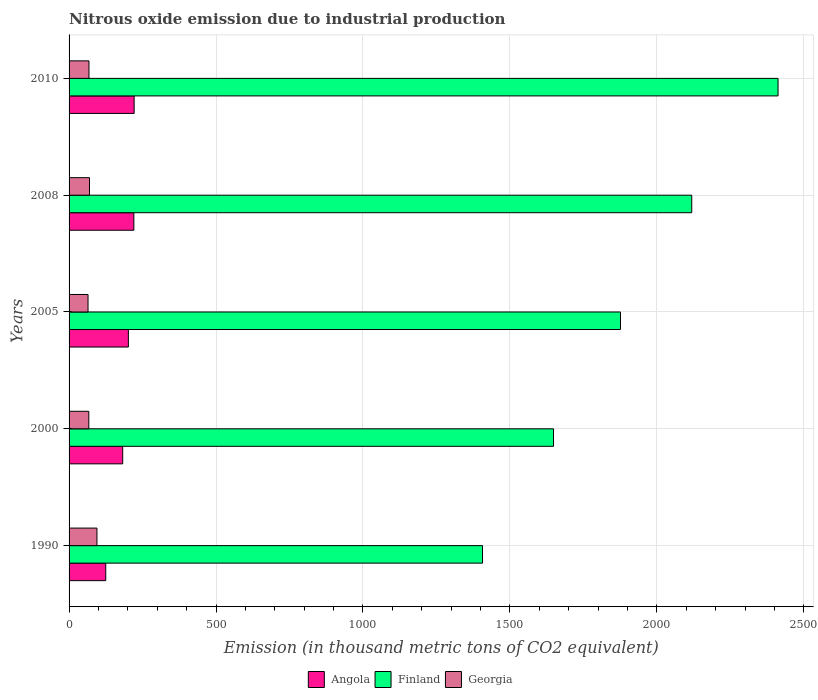How many different coloured bars are there?
Give a very brief answer. 3. How many groups of bars are there?
Your answer should be very brief. 5. Are the number of bars on each tick of the Y-axis equal?
Provide a succinct answer. Yes. How many bars are there on the 2nd tick from the bottom?
Offer a very short reply. 3. In how many cases, is the number of bars for a given year not equal to the number of legend labels?
Your response must be concise. 0. What is the amount of nitrous oxide emitted in Angola in 2005?
Ensure brevity in your answer.  201.8. Across all years, what is the maximum amount of nitrous oxide emitted in Georgia?
Ensure brevity in your answer.  94.9. Across all years, what is the minimum amount of nitrous oxide emitted in Angola?
Offer a very short reply. 124.8. What is the total amount of nitrous oxide emitted in Angola in the graph?
Offer a terse response. 950.9. What is the difference between the amount of nitrous oxide emitted in Angola in 2000 and that in 2010?
Provide a short and direct response. -38.9. What is the difference between the amount of nitrous oxide emitted in Angola in 1990 and the amount of nitrous oxide emitted in Finland in 2000?
Your answer should be very brief. -1523.6. What is the average amount of nitrous oxide emitted in Georgia per year?
Your answer should be compact. 72.76. In the year 1990, what is the difference between the amount of nitrous oxide emitted in Angola and amount of nitrous oxide emitted in Finland?
Offer a terse response. -1282. In how many years, is the amount of nitrous oxide emitted in Angola greater than 1800 thousand metric tons?
Ensure brevity in your answer.  0. What is the ratio of the amount of nitrous oxide emitted in Angola in 1990 to that in 2005?
Offer a very short reply. 0.62. Is the amount of nitrous oxide emitted in Angola in 2005 less than that in 2008?
Provide a short and direct response. Yes. What is the difference between the highest and the second highest amount of nitrous oxide emitted in Finland?
Give a very brief answer. 293.7. What is the difference between the highest and the lowest amount of nitrous oxide emitted in Georgia?
Your answer should be very brief. 30.4. What does the 2nd bar from the bottom in 2008 represents?
Provide a short and direct response. Finland. Does the graph contain grids?
Provide a short and direct response. Yes. How are the legend labels stacked?
Keep it short and to the point. Horizontal. What is the title of the graph?
Provide a succinct answer. Nitrous oxide emission due to industrial production. Does "Algeria" appear as one of the legend labels in the graph?
Provide a short and direct response. No. What is the label or title of the X-axis?
Give a very brief answer. Emission (in thousand metric tons of CO2 equivalent). What is the label or title of the Y-axis?
Provide a short and direct response. Years. What is the Emission (in thousand metric tons of CO2 equivalent) in Angola in 1990?
Your answer should be very brief. 124.8. What is the Emission (in thousand metric tons of CO2 equivalent) of Finland in 1990?
Your answer should be very brief. 1406.8. What is the Emission (in thousand metric tons of CO2 equivalent) of Georgia in 1990?
Keep it short and to the point. 94.9. What is the Emission (in thousand metric tons of CO2 equivalent) of Angola in 2000?
Your response must be concise. 182.5. What is the Emission (in thousand metric tons of CO2 equivalent) of Finland in 2000?
Provide a short and direct response. 1648.4. What is the Emission (in thousand metric tons of CO2 equivalent) of Georgia in 2000?
Make the answer very short. 67.2. What is the Emission (in thousand metric tons of CO2 equivalent) in Angola in 2005?
Make the answer very short. 201.8. What is the Emission (in thousand metric tons of CO2 equivalent) in Finland in 2005?
Your answer should be compact. 1876.3. What is the Emission (in thousand metric tons of CO2 equivalent) in Georgia in 2005?
Your response must be concise. 64.5. What is the Emission (in thousand metric tons of CO2 equivalent) of Angola in 2008?
Your response must be concise. 220.4. What is the Emission (in thousand metric tons of CO2 equivalent) of Finland in 2008?
Offer a very short reply. 2118.7. What is the Emission (in thousand metric tons of CO2 equivalent) in Georgia in 2008?
Offer a very short reply. 69.5. What is the Emission (in thousand metric tons of CO2 equivalent) in Angola in 2010?
Your response must be concise. 221.4. What is the Emission (in thousand metric tons of CO2 equivalent) of Finland in 2010?
Provide a succinct answer. 2412.4. What is the Emission (in thousand metric tons of CO2 equivalent) of Georgia in 2010?
Provide a short and direct response. 67.7. Across all years, what is the maximum Emission (in thousand metric tons of CO2 equivalent) in Angola?
Your answer should be very brief. 221.4. Across all years, what is the maximum Emission (in thousand metric tons of CO2 equivalent) in Finland?
Your answer should be compact. 2412.4. Across all years, what is the maximum Emission (in thousand metric tons of CO2 equivalent) in Georgia?
Give a very brief answer. 94.9. Across all years, what is the minimum Emission (in thousand metric tons of CO2 equivalent) in Angola?
Provide a short and direct response. 124.8. Across all years, what is the minimum Emission (in thousand metric tons of CO2 equivalent) of Finland?
Give a very brief answer. 1406.8. Across all years, what is the minimum Emission (in thousand metric tons of CO2 equivalent) of Georgia?
Keep it short and to the point. 64.5. What is the total Emission (in thousand metric tons of CO2 equivalent) in Angola in the graph?
Offer a terse response. 950.9. What is the total Emission (in thousand metric tons of CO2 equivalent) of Finland in the graph?
Your answer should be very brief. 9462.6. What is the total Emission (in thousand metric tons of CO2 equivalent) in Georgia in the graph?
Provide a short and direct response. 363.8. What is the difference between the Emission (in thousand metric tons of CO2 equivalent) in Angola in 1990 and that in 2000?
Provide a short and direct response. -57.7. What is the difference between the Emission (in thousand metric tons of CO2 equivalent) in Finland in 1990 and that in 2000?
Offer a very short reply. -241.6. What is the difference between the Emission (in thousand metric tons of CO2 equivalent) of Georgia in 1990 and that in 2000?
Make the answer very short. 27.7. What is the difference between the Emission (in thousand metric tons of CO2 equivalent) of Angola in 1990 and that in 2005?
Provide a succinct answer. -77. What is the difference between the Emission (in thousand metric tons of CO2 equivalent) in Finland in 1990 and that in 2005?
Make the answer very short. -469.5. What is the difference between the Emission (in thousand metric tons of CO2 equivalent) in Georgia in 1990 and that in 2005?
Provide a short and direct response. 30.4. What is the difference between the Emission (in thousand metric tons of CO2 equivalent) in Angola in 1990 and that in 2008?
Offer a terse response. -95.6. What is the difference between the Emission (in thousand metric tons of CO2 equivalent) in Finland in 1990 and that in 2008?
Give a very brief answer. -711.9. What is the difference between the Emission (in thousand metric tons of CO2 equivalent) in Georgia in 1990 and that in 2008?
Ensure brevity in your answer.  25.4. What is the difference between the Emission (in thousand metric tons of CO2 equivalent) in Angola in 1990 and that in 2010?
Keep it short and to the point. -96.6. What is the difference between the Emission (in thousand metric tons of CO2 equivalent) in Finland in 1990 and that in 2010?
Provide a short and direct response. -1005.6. What is the difference between the Emission (in thousand metric tons of CO2 equivalent) in Georgia in 1990 and that in 2010?
Offer a very short reply. 27.2. What is the difference between the Emission (in thousand metric tons of CO2 equivalent) of Angola in 2000 and that in 2005?
Offer a very short reply. -19.3. What is the difference between the Emission (in thousand metric tons of CO2 equivalent) in Finland in 2000 and that in 2005?
Give a very brief answer. -227.9. What is the difference between the Emission (in thousand metric tons of CO2 equivalent) of Georgia in 2000 and that in 2005?
Your response must be concise. 2.7. What is the difference between the Emission (in thousand metric tons of CO2 equivalent) in Angola in 2000 and that in 2008?
Make the answer very short. -37.9. What is the difference between the Emission (in thousand metric tons of CO2 equivalent) of Finland in 2000 and that in 2008?
Give a very brief answer. -470.3. What is the difference between the Emission (in thousand metric tons of CO2 equivalent) of Georgia in 2000 and that in 2008?
Provide a succinct answer. -2.3. What is the difference between the Emission (in thousand metric tons of CO2 equivalent) in Angola in 2000 and that in 2010?
Provide a succinct answer. -38.9. What is the difference between the Emission (in thousand metric tons of CO2 equivalent) in Finland in 2000 and that in 2010?
Provide a succinct answer. -764. What is the difference between the Emission (in thousand metric tons of CO2 equivalent) of Georgia in 2000 and that in 2010?
Provide a succinct answer. -0.5. What is the difference between the Emission (in thousand metric tons of CO2 equivalent) of Angola in 2005 and that in 2008?
Give a very brief answer. -18.6. What is the difference between the Emission (in thousand metric tons of CO2 equivalent) in Finland in 2005 and that in 2008?
Give a very brief answer. -242.4. What is the difference between the Emission (in thousand metric tons of CO2 equivalent) in Georgia in 2005 and that in 2008?
Make the answer very short. -5. What is the difference between the Emission (in thousand metric tons of CO2 equivalent) of Angola in 2005 and that in 2010?
Keep it short and to the point. -19.6. What is the difference between the Emission (in thousand metric tons of CO2 equivalent) in Finland in 2005 and that in 2010?
Give a very brief answer. -536.1. What is the difference between the Emission (in thousand metric tons of CO2 equivalent) of Angola in 2008 and that in 2010?
Make the answer very short. -1. What is the difference between the Emission (in thousand metric tons of CO2 equivalent) of Finland in 2008 and that in 2010?
Your answer should be very brief. -293.7. What is the difference between the Emission (in thousand metric tons of CO2 equivalent) in Angola in 1990 and the Emission (in thousand metric tons of CO2 equivalent) in Finland in 2000?
Your answer should be compact. -1523.6. What is the difference between the Emission (in thousand metric tons of CO2 equivalent) of Angola in 1990 and the Emission (in thousand metric tons of CO2 equivalent) of Georgia in 2000?
Your answer should be very brief. 57.6. What is the difference between the Emission (in thousand metric tons of CO2 equivalent) of Finland in 1990 and the Emission (in thousand metric tons of CO2 equivalent) of Georgia in 2000?
Make the answer very short. 1339.6. What is the difference between the Emission (in thousand metric tons of CO2 equivalent) in Angola in 1990 and the Emission (in thousand metric tons of CO2 equivalent) in Finland in 2005?
Provide a short and direct response. -1751.5. What is the difference between the Emission (in thousand metric tons of CO2 equivalent) of Angola in 1990 and the Emission (in thousand metric tons of CO2 equivalent) of Georgia in 2005?
Your answer should be very brief. 60.3. What is the difference between the Emission (in thousand metric tons of CO2 equivalent) of Finland in 1990 and the Emission (in thousand metric tons of CO2 equivalent) of Georgia in 2005?
Ensure brevity in your answer.  1342.3. What is the difference between the Emission (in thousand metric tons of CO2 equivalent) in Angola in 1990 and the Emission (in thousand metric tons of CO2 equivalent) in Finland in 2008?
Your response must be concise. -1993.9. What is the difference between the Emission (in thousand metric tons of CO2 equivalent) of Angola in 1990 and the Emission (in thousand metric tons of CO2 equivalent) of Georgia in 2008?
Your answer should be very brief. 55.3. What is the difference between the Emission (in thousand metric tons of CO2 equivalent) of Finland in 1990 and the Emission (in thousand metric tons of CO2 equivalent) of Georgia in 2008?
Ensure brevity in your answer.  1337.3. What is the difference between the Emission (in thousand metric tons of CO2 equivalent) of Angola in 1990 and the Emission (in thousand metric tons of CO2 equivalent) of Finland in 2010?
Offer a terse response. -2287.6. What is the difference between the Emission (in thousand metric tons of CO2 equivalent) of Angola in 1990 and the Emission (in thousand metric tons of CO2 equivalent) of Georgia in 2010?
Keep it short and to the point. 57.1. What is the difference between the Emission (in thousand metric tons of CO2 equivalent) of Finland in 1990 and the Emission (in thousand metric tons of CO2 equivalent) of Georgia in 2010?
Your answer should be compact. 1339.1. What is the difference between the Emission (in thousand metric tons of CO2 equivalent) of Angola in 2000 and the Emission (in thousand metric tons of CO2 equivalent) of Finland in 2005?
Your answer should be compact. -1693.8. What is the difference between the Emission (in thousand metric tons of CO2 equivalent) of Angola in 2000 and the Emission (in thousand metric tons of CO2 equivalent) of Georgia in 2005?
Give a very brief answer. 118. What is the difference between the Emission (in thousand metric tons of CO2 equivalent) in Finland in 2000 and the Emission (in thousand metric tons of CO2 equivalent) in Georgia in 2005?
Offer a terse response. 1583.9. What is the difference between the Emission (in thousand metric tons of CO2 equivalent) in Angola in 2000 and the Emission (in thousand metric tons of CO2 equivalent) in Finland in 2008?
Your answer should be very brief. -1936.2. What is the difference between the Emission (in thousand metric tons of CO2 equivalent) in Angola in 2000 and the Emission (in thousand metric tons of CO2 equivalent) in Georgia in 2008?
Make the answer very short. 113. What is the difference between the Emission (in thousand metric tons of CO2 equivalent) of Finland in 2000 and the Emission (in thousand metric tons of CO2 equivalent) of Georgia in 2008?
Keep it short and to the point. 1578.9. What is the difference between the Emission (in thousand metric tons of CO2 equivalent) in Angola in 2000 and the Emission (in thousand metric tons of CO2 equivalent) in Finland in 2010?
Your response must be concise. -2229.9. What is the difference between the Emission (in thousand metric tons of CO2 equivalent) of Angola in 2000 and the Emission (in thousand metric tons of CO2 equivalent) of Georgia in 2010?
Ensure brevity in your answer.  114.8. What is the difference between the Emission (in thousand metric tons of CO2 equivalent) of Finland in 2000 and the Emission (in thousand metric tons of CO2 equivalent) of Georgia in 2010?
Keep it short and to the point. 1580.7. What is the difference between the Emission (in thousand metric tons of CO2 equivalent) in Angola in 2005 and the Emission (in thousand metric tons of CO2 equivalent) in Finland in 2008?
Your answer should be compact. -1916.9. What is the difference between the Emission (in thousand metric tons of CO2 equivalent) in Angola in 2005 and the Emission (in thousand metric tons of CO2 equivalent) in Georgia in 2008?
Keep it short and to the point. 132.3. What is the difference between the Emission (in thousand metric tons of CO2 equivalent) in Finland in 2005 and the Emission (in thousand metric tons of CO2 equivalent) in Georgia in 2008?
Your answer should be very brief. 1806.8. What is the difference between the Emission (in thousand metric tons of CO2 equivalent) of Angola in 2005 and the Emission (in thousand metric tons of CO2 equivalent) of Finland in 2010?
Offer a very short reply. -2210.6. What is the difference between the Emission (in thousand metric tons of CO2 equivalent) in Angola in 2005 and the Emission (in thousand metric tons of CO2 equivalent) in Georgia in 2010?
Your answer should be very brief. 134.1. What is the difference between the Emission (in thousand metric tons of CO2 equivalent) in Finland in 2005 and the Emission (in thousand metric tons of CO2 equivalent) in Georgia in 2010?
Provide a succinct answer. 1808.6. What is the difference between the Emission (in thousand metric tons of CO2 equivalent) of Angola in 2008 and the Emission (in thousand metric tons of CO2 equivalent) of Finland in 2010?
Ensure brevity in your answer.  -2192. What is the difference between the Emission (in thousand metric tons of CO2 equivalent) in Angola in 2008 and the Emission (in thousand metric tons of CO2 equivalent) in Georgia in 2010?
Provide a short and direct response. 152.7. What is the difference between the Emission (in thousand metric tons of CO2 equivalent) in Finland in 2008 and the Emission (in thousand metric tons of CO2 equivalent) in Georgia in 2010?
Your response must be concise. 2051. What is the average Emission (in thousand metric tons of CO2 equivalent) in Angola per year?
Provide a succinct answer. 190.18. What is the average Emission (in thousand metric tons of CO2 equivalent) of Finland per year?
Offer a terse response. 1892.52. What is the average Emission (in thousand metric tons of CO2 equivalent) of Georgia per year?
Provide a succinct answer. 72.76. In the year 1990, what is the difference between the Emission (in thousand metric tons of CO2 equivalent) of Angola and Emission (in thousand metric tons of CO2 equivalent) of Finland?
Your response must be concise. -1282. In the year 1990, what is the difference between the Emission (in thousand metric tons of CO2 equivalent) in Angola and Emission (in thousand metric tons of CO2 equivalent) in Georgia?
Offer a very short reply. 29.9. In the year 1990, what is the difference between the Emission (in thousand metric tons of CO2 equivalent) in Finland and Emission (in thousand metric tons of CO2 equivalent) in Georgia?
Provide a short and direct response. 1311.9. In the year 2000, what is the difference between the Emission (in thousand metric tons of CO2 equivalent) of Angola and Emission (in thousand metric tons of CO2 equivalent) of Finland?
Offer a terse response. -1465.9. In the year 2000, what is the difference between the Emission (in thousand metric tons of CO2 equivalent) in Angola and Emission (in thousand metric tons of CO2 equivalent) in Georgia?
Your response must be concise. 115.3. In the year 2000, what is the difference between the Emission (in thousand metric tons of CO2 equivalent) in Finland and Emission (in thousand metric tons of CO2 equivalent) in Georgia?
Offer a terse response. 1581.2. In the year 2005, what is the difference between the Emission (in thousand metric tons of CO2 equivalent) in Angola and Emission (in thousand metric tons of CO2 equivalent) in Finland?
Provide a short and direct response. -1674.5. In the year 2005, what is the difference between the Emission (in thousand metric tons of CO2 equivalent) in Angola and Emission (in thousand metric tons of CO2 equivalent) in Georgia?
Ensure brevity in your answer.  137.3. In the year 2005, what is the difference between the Emission (in thousand metric tons of CO2 equivalent) of Finland and Emission (in thousand metric tons of CO2 equivalent) of Georgia?
Provide a short and direct response. 1811.8. In the year 2008, what is the difference between the Emission (in thousand metric tons of CO2 equivalent) of Angola and Emission (in thousand metric tons of CO2 equivalent) of Finland?
Provide a succinct answer. -1898.3. In the year 2008, what is the difference between the Emission (in thousand metric tons of CO2 equivalent) of Angola and Emission (in thousand metric tons of CO2 equivalent) of Georgia?
Offer a very short reply. 150.9. In the year 2008, what is the difference between the Emission (in thousand metric tons of CO2 equivalent) in Finland and Emission (in thousand metric tons of CO2 equivalent) in Georgia?
Make the answer very short. 2049.2. In the year 2010, what is the difference between the Emission (in thousand metric tons of CO2 equivalent) of Angola and Emission (in thousand metric tons of CO2 equivalent) of Finland?
Your answer should be compact. -2191. In the year 2010, what is the difference between the Emission (in thousand metric tons of CO2 equivalent) of Angola and Emission (in thousand metric tons of CO2 equivalent) of Georgia?
Provide a short and direct response. 153.7. In the year 2010, what is the difference between the Emission (in thousand metric tons of CO2 equivalent) in Finland and Emission (in thousand metric tons of CO2 equivalent) in Georgia?
Offer a very short reply. 2344.7. What is the ratio of the Emission (in thousand metric tons of CO2 equivalent) of Angola in 1990 to that in 2000?
Your answer should be compact. 0.68. What is the ratio of the Emission (in thousand metric tons of CO2 equivalent) of Finland in 1990 to that in 2000?
Offer a terse response. 0.85. What is the ratio of the Emission (in thousand metric tons of CO2 equivalent) in Georgia in 1990 to that in 2000?
Provide a short and direct response. 1.41. What is the ratio of the Emission (in thousand metric tons of CO2 equivalent) in Angola in 1990 to that in 2005?
Make the answer very short. 0.62. What is the ratio of the Emission (in thousand metric tons of CO2 equivalent) in Finland in 1990 to that in 2005?
Your response must be concise. 0.75. What is the ratio of the Emission (in thousand metric tons of CO2 equivalent) of Georgia in 1990 to that in 2005?
Your response must be concise. 1.47. What is the ratio of the Emission (in thousand metric tons of CO2 equivalent) in Angola in 1990 to that in 2008?
Make the answer very short. 0.57. What is the ratio of the Emission (in thousand metric tons of CO2 equivalent) in Finland in 1990 to that in 2008?
Your answer should be compact. 0.66. What is the ratio of the Emission (in thousand metric tons of CO2 equivalent) in Georgia in 1990 to that in 2008?
Provide a short and direct response. 1.37. What is the ratio of the Emission (in thousand metric tons of CO2 equivalent) of Angola in 1990 to that in 2010?
Your answer should be compact. 0.56. What is the ratio of the Emission (in thousand metric tons of CO2 equivalent) in Finland in 1990 to that in 2010?
Your response must be concise. 0.58. What is the ratio of the Emission (in thousand metric tons of CO2 equivalent) of Georgia in 1990 to that in 2010?
Provide a succinct answer. 1.4. What is the ratio of the Emission (in thousand metric tons of CO2 equivalent) of Angola in 2000 to that in 2005?
Your response must be concise. 0.9. What is the ratio of the Emission (in thousand metric tons of CO2 equivalent) in Finland in 2000 to that in 2005?
Keep it short and to the point. 0.88. What is the ratio of the Emission (in thousand metric tons of CO2 equivalent) of Georgia in 2000 to that in 2005?
Offer a very short reply. 1.04. What is the ratio of the Emission (in thousand metric tons of CO2 equivalent) in Angola in 2000 to that in 2008?
Give a very brief answer. 0.83. What is the ratio of the Emission (in thousand metric tons of CO2 equivalent) of Finland in 2000 to that in 2008?
Offer a very short reply. 0.78. What is the ratio of the Emission (in thousand metric tons of CO2 equivalent) in Georgia in 2000 to that in 2008?
Your answer should be very brief. 0.97. What is the ratio of the Emission (in thousand metric tons of CO2 equivalent) in Angola in 2000 to that in 2010?
Provide a short and direct response. 0.82. What is the ratio of the Emission (in thousand metric tons of CO2 equivalent) in Finland in 2000 to that in 2010?
Offer a very short reply. 0.68. What is the ratio of the Emission (in thousand metric tons of CO2 equivalent) of Angola in 2005 to that in 2008?
Provide a short and direct response. 0.92. What is the ratio of the Emission (in thousand metric tons of CO2 equivalent) in Finland in 2005 to that in 2008?
Your answer should be compact. 0.89. What is the ratio of the Emission (in thousand metric tons of CO2 equivalent) in Georgia in 2005 to that in 2008?
Provide a succinct answer. 0.93. What is the ratio of the Emission (in thousand metric tons of CO2 equivalent) in Angola in 2005 to that in 2010?
Give a very brief answer. 0.91. What is the ratio of the Emission (in thousand metric tons of CO2 equivalent) of Georgia in 2005 to that in 2010?
Your answer should be very brief. 0.95. What is the ratio of the Emission (in thousand metric tons of CO2 equivalent) of Finland in 2008 to that in 2010?
Give a very brief answer. 0.88. What is the ratio of the Emission (in thousand metric tons of CO2 equivalent) of Georgia in 2008 to that in 2010?
Offer a very short reply. 1.03. What is the difference between the highest and the second highest Emission (in thousand metric tons of CO2 equivalent) in Angola?
Provide a succinct answer. 1. What is the difference between the highest and the second highest Emission (in thousand metric tons of CO2 equivalent) in Finland?
Ensure brevity in your answer.  293.7. What is the difference between the highest and the second highest Emission (in thousand metric tons of CO2 equivalent) in Georgia?
Make the answer very short. 25.4. What is the difference between the highest and the lowest Emission (in thousand metric tons of CO2 equivalent) in Angola?
Give a very brief answer. 96.6. What is the difference between the highest and the lowest Emission (in thousand metric tons of CO2 equivalent) in Finland?
Give a very brief answer. 1005.6. What is the difference between the highest and the lowest Emission (in thousand metric tons of CO2 equivalent) in Georgia?
Offer a terse response. 30.4. 